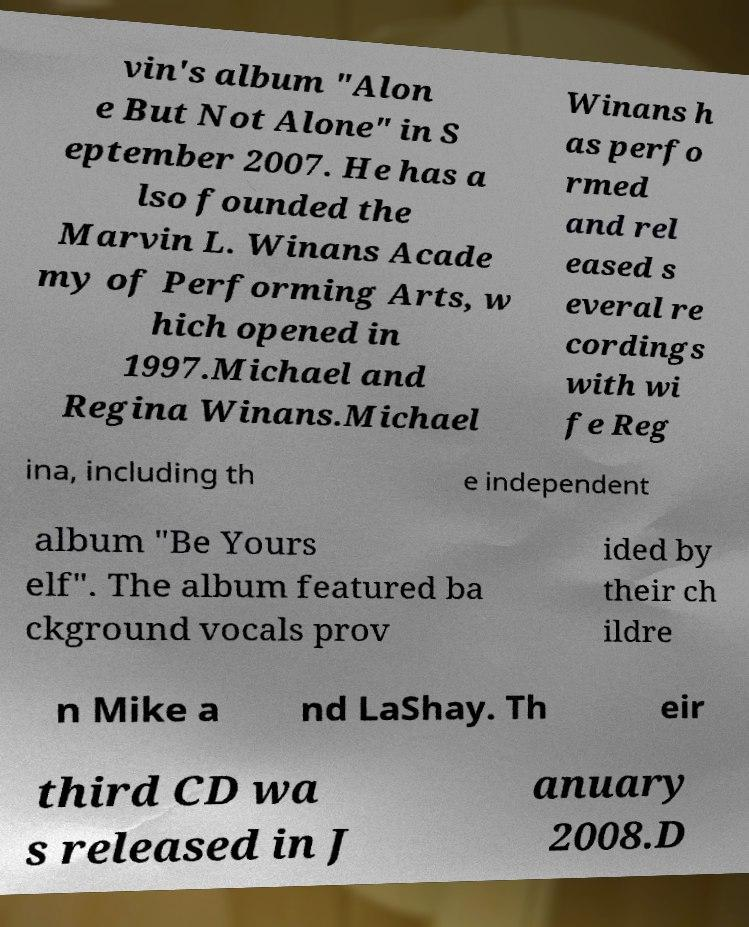There's text embedded in this image that I need extracted. Can you transcribe it verbatim? vin's album "Alon e But Not Alone" in S eptember 2007. He has a lso founded the Marvin L. Winans Acade my of Performing Arts, w hich opened in 1997.Michael and Regina Winans.Michael Winans h as perfo rmed and rel eased s everal re cordings with wi fe Reg ina, including th e independent album "Be Yours elf". The album featured ba ckground vocals prov ided by their ch ildre n Mike a nd LaShay. Th eir third CD wa s released in J anuary 2008.D 